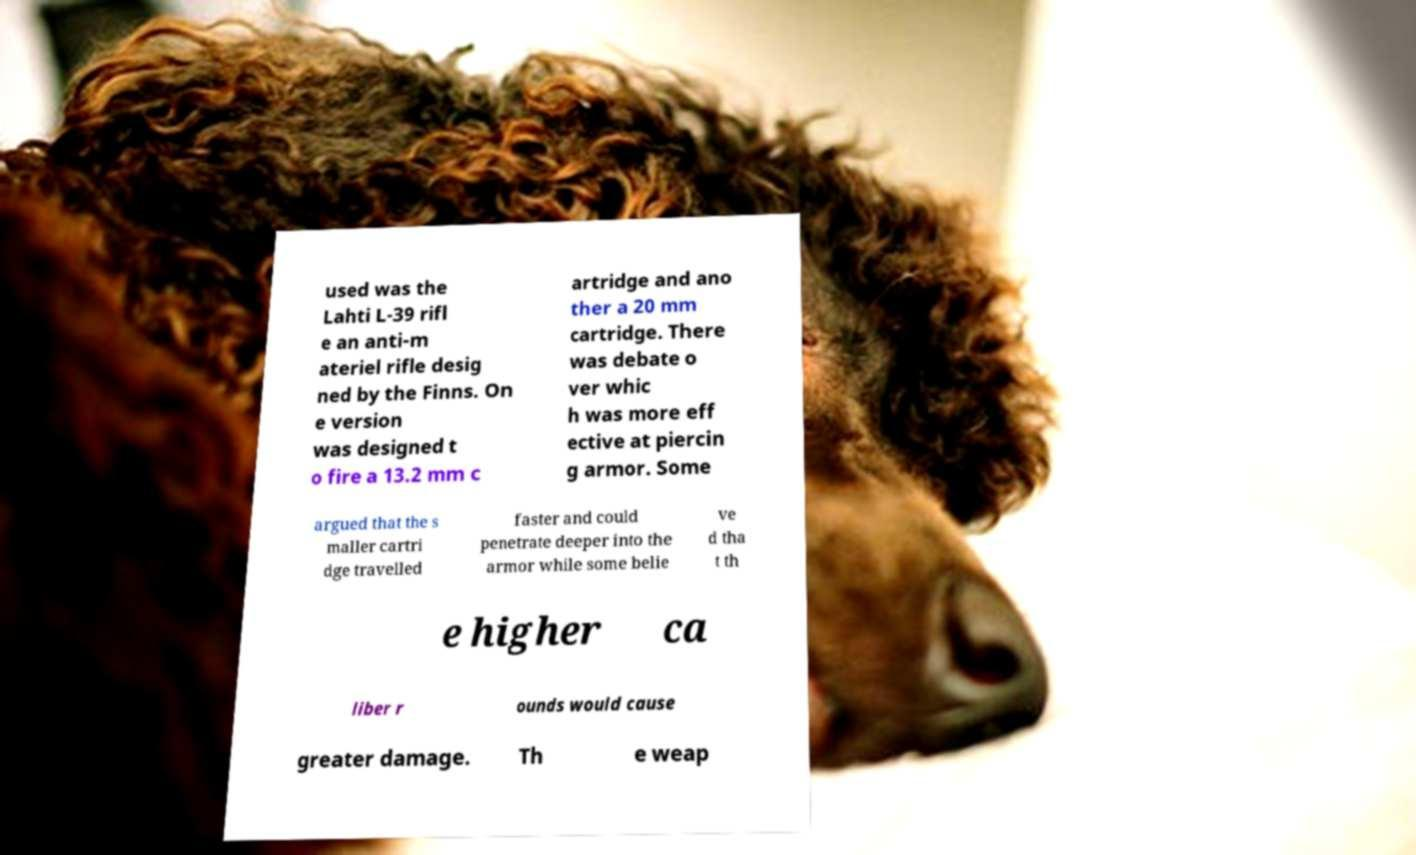For documentation purposes, I need the text within this image transcribed. Could you provide that? used was the Lahti L-39 rifl e an anti-m ateriel rifle desig ned by the Finns. On e version was designed t o fire a 13.2 mm c artridge and ano ther a 20 mm cartridge. There was debate o ver whic h was more eff ective at piercin g armor. Some argued that the s maller cartri dge travelled faster and could penetrate deeper into the armor while some belie ve d tha t th e higher ca liber r ounds would cause greater damage. Th e weap 